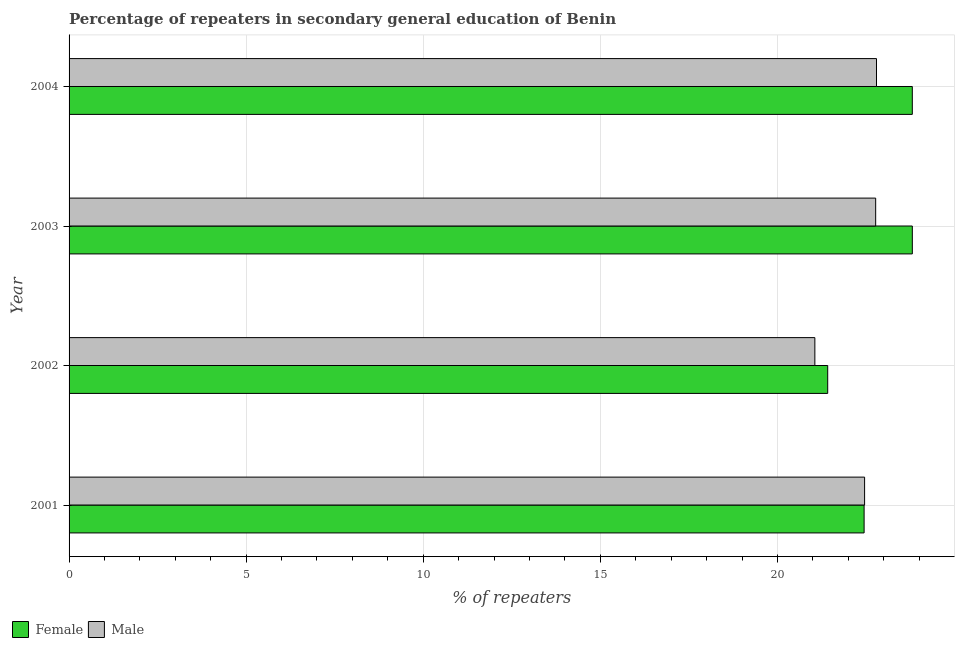How many different coloured bars are there?
Offer a terse response. 2. Are the number of bars per tick equal to the number of legend labels?
Offer a terse response. Yes. Are the number of bars on each tick of the Y-axis equal?
Your answer should be compact. Yes. How many bars are there on the 2nd tick from the top?
Provide a succinct answer. 2. What is the label of the 4th group of bars from the top?
Your answer should be compact. 2001. What is the percentage of male repeaters in 2003?
Make the answer very short. 22.77. Across all years, what is the maximum percentage of female repeaters?
Provide a short and direct response. 23.81. Across all years, what is the minimum percentage of female repeaters?
Provide a succinct answer. 21.42. In which year was the percentage of female repeaters maximum?
Provide a succinct answer. 2003. What is the total percentage of female repeaters in the graph?
Your response must be concise. 91.49. What is the difference between the percentage of male repeaters in 2001 and that in 2003?
Keep it short and to the point. -0.31. What is the difference between the percentage of male repeaters in 2002 and the percentage of female repeaters in 2004?
Keep it short and to the point. -2.75. What is the average percentage of male repeaters per year?
Your response must be concise. 22.27. In the year 2002, what is the difference between the percentage of female repeaters and percentage of male repeaters?
Make the answer very short. 0.36. Is the percentage of female repeaters in 2002 less than that in 2003?
Provide a succinct answer. Yes. What is the difference between the highest and the second highest percentage of female repeaters?
Offer a very short reply. 0. What is the difference between the highest and the lowest percentage of male repeaters?
Offer a terse response. 1.74. In how many years, is the percentage of male repeaters greater than the average percentage of male repeaters taken over all years?
Provide a short and direct response. 3. Are all the bars in the graph horizontal?
Offer a terse response. Yes. How many years are there in the graph?
Ensure brevity in your answer.  4. Are the values on the major ticks of X-axis written in scientific E-notation?
Offer a very short reply. No. Where does the legend appear in the graph?
Your response must be concise. Bottom left. How are the legend labels stacked?
Give a very brief answer. Horizontal. What is the title of the graph?
Ensure brevity in your answer.  Percentage of repeaters in secondary general education of Benin. Does "Domestic Liabilities" appear as one of the legend labels in the graph?
Make the answer very short. No. What is the label or title of the X-axis?
Give a very brief answer. % of repeaters. What is the label or title of the Y-axis?
Your response must be concise. Year. What is the % of repeaters in Female in 2001?
Offer a very short reply. 22.45. What is the % of repeaters of Male in 2001?
Your response must be concise. 22.46. What is the % of repeaters of Female in 2002?
Keep it short and to the point. 21.42. What is the % of repeaters in Male in 2002?
Ensure brevity in your answer.  21.06. What is the % of repeaters of Female in 2003?
Your response must be concise. 23.81. What is the % of repeaters of Male in 2003?
Provide a short and direct response. 22.77. What is the % of repeaters of Female in 2004?
Your answer should be compact. 23.81. What is the % of repeaters of Male in 2004?
Your answer should be compact. 22.8. Across all years, what is the maximum % of repeaters in Female?
Give a very brief answer. 23.81. Across all years, what is the maximum % of repeaters in Male?
Make the answer very short. 22.8. Across all years, what is the minimum % of repeaters in Female?
Make the answer very short. 21.42. Across all years, what is the minimum % of repeaters in Male?
Your answer should be very brief. 21.06. What is the total % of repeaters in Female in the graph?
Keep it short and to the point. 91.49. What is the total % of repeaters in Male in the graph?
Keep it short and to the point. 89.09. What is the difference between the % of repeaters in Female in 2001 and that in 2002?
Offer a terse response. 1.03. What is the difference between the % of repeaters of Male in 2001 and that in 2002?
Give a very brief answer. 1.4. What is the difference between the % of repeaters in Female in 2001 and that in 2003?
Provide a short and direct response. -1.36. What is the difference between the % of repeaters of Male in 2001 and that in 2003?
Ensure brevity in your answer.  -0.31. What is the difference between the % of repeaters of Female in 2001 and that in 2004?
Your response must be concise. -1.36. What is the difference between the % of repeaters of Male in 2001 and that in 2004?
Your response must be concise. -0.34. What is the difference between the % of repeaters of Female in 2002 and that in 2003?
Provide a succinct answer. -2.39. What is the difference between the % of repeaters of Male in 2002 and that in 2003?
Provide a short and direct response. -1.72. What is the difference between the % of repeaters of Female in 2002 and that in 2004?
Give a very brief answer. -2.39. What is the difference between the % of repeaters in Male in 2002 and that in 2004?
Provide a short and direct response. -1.74. What is the difference between the % of repeaters in Male in 2003 and that in 2004?
Provide a short and direct response. -0.02. What is the difference between the % of repeaters of Female in 2001 and the % of repeaters of Male in 2002?
Your answer should be very brief. 1.39. What is the difference between the % of repeaters in Female in 2001 and the % of repeaters in Male in 2003?
Your answer should be compact. -0.33. What is the difference between the % of repeaters in Female in 2001 and the % of repeaters in Male in 2004?
Offer a very short reply. -0.35. What is the difference between the % of repeaters of Female in 2002 and the % of repeaters of Male in 2003?
Provide a succinct answer. -1.35. What is the difference between the % of repeaters of Female in 2002 and the % of repeaters of Male in 2004?
Provide a succinct answer. -1.38. What is the difference between the % of repeaters in Female in 2003 and the % of repeaters in Male in 2004?
Make the answer very short. 1.01. What is the average % of repeaters of Female per year?
Give a very brief answer. 22.87. What is the average % of repeaters in Male per year?
Provide a succinct answer. 22.27. In the year 2001, what is the difference between the % of repeaters of Female and % of repeaters of Male?
Ensure brevity in your answer.  -0.01. In the year 2002, what is the difference between the % of repeaters in Female and % of repeaters in Male?
Give a very brief answer. 0.36. In the year 2003, what is the difference between the % of repeaters of Female and % of repeaters of Male?
Your response must be concise. 1.04. In the year 2004, what is the difference between the % of repeaters of Female and % of repeaters of Male?
Give a very brief answer. 1.01. What is the ratio of the % of repeaters in Female in 2001 to that in 2002?
Provide a short and direct response. 1.05. What is the ratio of the % of repeaters in Male in 2001 to that in 2002?
Give a very brief answer. 1.07. What is the ratio of the % of repeaters in Female in 2001 to that in 2003?
Your answer should be very brief. 0.94. What is the ratio of the % of repeaters in Male in 2001 to that in 2003?
Your response must be concise. 0.99. What is the ratio of the % of repeaters of Female in 2001 to that in 2004?
Ensure brevity in your answer.  0.94. What is the ratio of the % of repeaters in Female in 2002 to that in 2003?
Make the answer very short. 0.9. What is the ratio of the % of repeaters in Male in 2002 to that in 2003?
Your answer should be very brief. 0.92. What is the ratio of the % of repeaters in Female in 2002 to that in 2004?
Keep it short and to the point. 0.9. What is the ratio of the % of repeaters in Male in 2002 to that in 2004?
Keep it short and to the point. 0.92. What is the ratio of the % of repeaters of Female in 2003 to that in 2004?
Your answer should be compact. 1. What is the ratio of the % of repeaters of Male in 2003 to that in 2004?
Offer a very short reply. 1. What is the difference between the highest and the second highest % of repeaters in Female?
Provide a short and direct response. 0. What is the difference between the highest and the second highest % of repeaters in Male?
Give a very brief answer. 0.02. What is the difference between the highest and the lowest % of repeaters in Female?
Offer a very short reply. 2.39. What is the difference between the highest and the lowest % of repeaters of Male?
Make the answer very short. 1.74. 